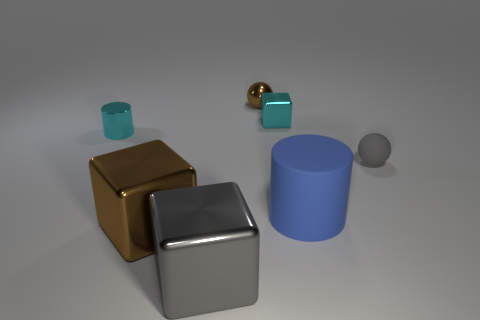Add 2 tiny metallic things. How many objects exist? 9 Subtract all cylinders. How many objects are left? 5 Add 4 big gray metallic objects. How many big gray metallic objects are left? 5 Add 4 large gray metallic cubes. How many large gray metallic cubes exist? 5 Subtract 0 purple balls. How many objects are left? 7 Subtract all tiny objects. Subtract all big gray metal blocks. How many objects are left? 2 